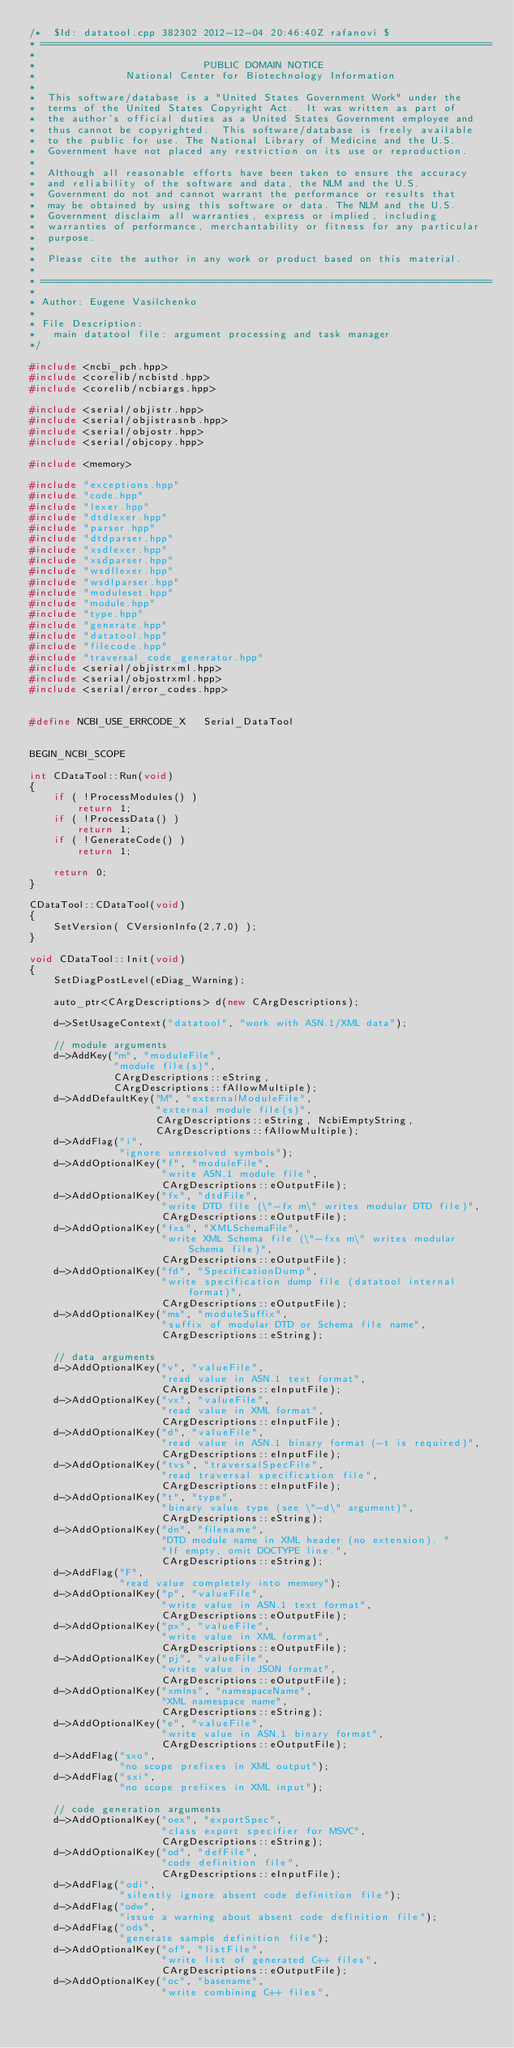Convert code to text. <code><loc_0><loc_0><loc_500><loc_500><_C++_>/*  $Id: datatool.cpp 382302 2012-12-04 20:46:40Z rafanovi $
* ===========================================================================
*
*                            PUBLIC DOMAIN NOTICE
*               National Center for Biotechnology Information
*
*  This software/database is a "United States Government Work" under the
*  terms of the United States Copyright Act.  It was written as part of
*  the author's official duties as a United States Government employee and
*  thus cannot be copyrighted.  This software/database is freely available
*  to the public for use. The National Library of Medicine and the U.S.
*  Government have not placed any restriction on its use or reproduction.
*
*  Although all reasonable efforts have been taken to ensure the accuracy
*  and reliability of the software and data, the NLM and the U.S.
*  Government do not and cannot warrant the performance or results that
*  may be obtained by using this software or data. The NLM and the U.S.
*  Government disclaim all warranties, express or implied, including
*  warranties of performance, merchantability or fitness for any particular
*  purpose.
*
*  Please cite the author in any work or product based on this material.
*
* ===========================================================================
*
* Author: Eugene Vasilchenko
*
* File Description:
*   main datatool file: argument processing and task manager
*/

#include <ncbi_pch.hpp>
#include <corelib/ncbistd.hpp>
#include <corelib/ncbiargs.hpp>

#include <serial/objistr.hpp>
#include <serial/objistrasnb.hpp>
#include <serial/objostr.hpp>
#include <serial/objcopy.hpp>

#include <memory>

#include "exceptions.hpp"
#include "code.hpp"
#include "lexer.hpp"
#include "dtdlexer.hpp"
#include "parser.hpp"
#include "dtdparser.hpp"
#include "xsdlexer.hpp"
#include "xsdparser.hpp"
#include "wsdllexer.hpp"
#include "wsdlparser.hpp"
#include "moduleset.hpp"
#include "module.hpp"
#include "type.hpp"
#include "generate.hpp"
#include "datatool.hpp"
#include "filecode.hpp"
#include "traversal_code_generator.hpp"
#include <serial/objistrxml.hpp>
#include <serial/objostrxml.hpp>
#include <serial/error_codes.hpp>


#define NCBI_USE_ERRCODE_X   Serial_DataTool


BEGIN_NCBI_SCOPE

int CDataTool::Run(void)
{
    if ( !ProcessModules() )
        return 1;
    if ( !ProcessData() )
        return 1;
    if ( !GenerateCode() )
        return 1;

    return 0;
}

CDataTool::CDataTool(void)
{
    SetVersion( CVersionInfo(2,7,0) );
}

void CDataTool::Init(void)
{
    SetDiagPostLevel(eDiag_Warning);

    auto_ptr<CArgDescriptions> d(new CArgDescriptions);

    d->SetUsageContext("datatool", "work with ASN.1/XML data");

    // module arguments
    d->AddKey("m", "moduleFile",
              "module file(s)",
              CArgDescriptions::eString,
              CArgDescriptions::fAllowMultiple);
    d->AddDefaultKey("M", "externalModuleFile",
                     "external module file(s)",
                     CArgDescriptions::eString, NcbiEmptyString,
                     CArgDescriptions::fAllowMultiple);
    d->AddFlag("i",
               "ignore unresolved symbols");
    d->AddOptionalKey("f", "moduleFile",
                      "write ASN.1 module file",
                      CArgDescriptions::eOutputFile);
    d->AddOptionalKey("fx", "dtdFile",
                      "write DTD file (\"-fx m\" writes modular DTD file)",
                      CArgDescriptions::eOutputFile);
    d->AddOptionalKey("fxs", "XMLSchemaFile",
                      "write XML Schema file (\"-fxs m\" writes modular Schema file)",
                      CArgDescriptions::eOutputFile);
    d->AddOptionalKey("fd", "SpecificationDump",
                      "write specification dump file (datatool internal format)",
                      CArgDescriptions::eOutputFile);
    d->AddOptionalKey("ms", "moduleSuffix",
                      "suffix of modular DTD or Schema file name",
                      CArgDescriptions::eString);

    // data arguments
    d->AddOptionalKey("v", "valueFile",
                      "read value in ASN.1 text format",
                      CArgDescriptions::eInputFile);
    d->AddOptionalKey("vx", "valueFile",
                      "read value in XML format",
                      CArgDescriptions::eInputFile);
    d->AddOptionalKey("d", "valueFile",
                      "read value in ASN.1 binary format (-t is required)",
                      CArgDescriptions::eInputFile);
    d->AddOptionalKey("tvs", "traversalSpecFile",
                      "read traversal specification file",
                      CArgDescriptions::eInputFile);
    d->AddOptionalKey("t", "type",
                      "binary value type (see \"-d\" argument)",
                      CArgDescriptions::eString);
    d->AddOptionalKey("dn", "filename",
                      "DTD module name in XML header (no extension). "
                      "If empty, omit DOCTYPE line.",
                      CArgDescriptions::eString);
    d->AddFlag("F",
               "read value completely into memory");
    d->AddOptionalKey("p", "valueFile",
                      "write value in ASN.1 text format",
                      CArgDescriptions::eOutputFile);
    d->AddOptionalKey("px", "valueFile",
                      "write value in XML format",
                      CArgDescriptions::eOutputFile);
    d->AddOptionalKey("pj", "valueFile",
                      "write value in JSON format",
                      CArgDescriptions::eOutputFile);
    d->AddOptionalKey("xmlns", "namespaceName",
                      "XML namespace name",
                      CArgDescriptions::eString);
    d->AddOptionalKey("e", "valueFile",
                      "write value in ASN.1 binary format",
                      CArgDescriptions::eOutputFile);
    d->AddFlag("sxo",
               "no scope prefixes in XML output");
    d->AddFlag("sxi",
               "no scope prefixes in XML input");

    // code generation arguments
    d->AddOptionalKey("oex", "exportSpec",
                      "class export specifier for MSVC",
                      CArgDescriptions::eString);
    d->AddOptionalKey("od", "defFile",
                      "code definition file",
                      CArgDescriptions::eInputFile);
    d->AddFlag("odi",
               "silently ignore absent code definition file");
    d->AddFlag("odw",
               "issue a warning about absent code definition file");
    d->AddFlag("ods",
               "generate sample definition file");
    d->AddOptionalKey("of", "listFile",
                      "write list of generated C++ files",
                      CArgDescriptions::eOutputFile);
    d->AddOptionalKey("oc", "basename",
                      "write combining C++ files",</code> 